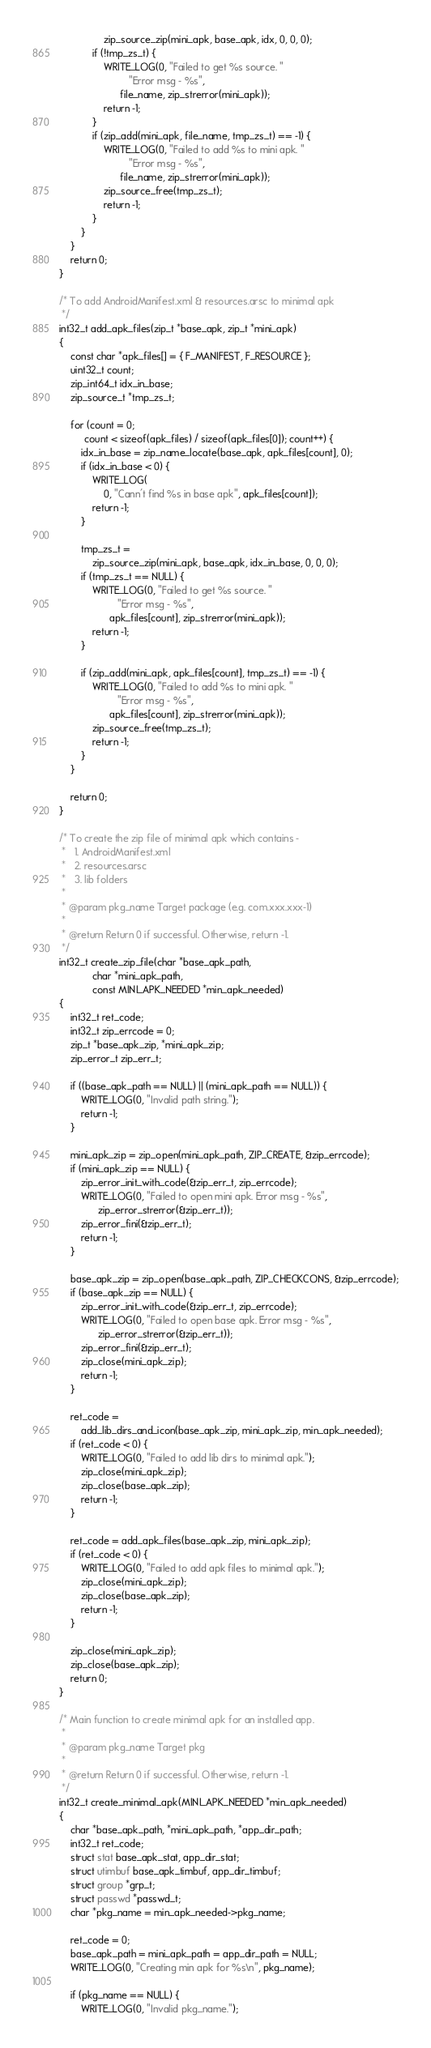<code> <loc_0><loc_0><loc_500><loc_500><_C_>			    zip_source_zip(mini_apk, base_apk, idx, 0, 0, 0);
			if (!tmp_zs_t) {
				WRITE_LOG(0, "Failed to get %s source. "
					     "Error msg - %s",
					  file_name, zip_strerror(mini_apk));
				return -1;
			}
			if (zip_add(mini_apk, file_name, tmp_zs_t) == -1) {
				WRITE_LOG(0, "Failed to add %s to mini apk. "
					     "Error msg - %s",
					  file_name, zip_strerror(mini_apk));
				zip_source_free(tmp_zs_t);
				return -1;
			}
		}
	}
	return 0;
}

/* To add AndroidManifest.xml & resources.arsc to minimal apk
 */
int32_t add_apk_files(zip_t *base_apk, zip_t *mini_apk)
{
	const char *apk_files[] = { F_MANIFEST, F_RESOURCE };
	uint32_t count;
	zip_int64_t idx_in_base;
	zip_source_t *tmp_zs_t;

	for (count = 0;
	     count < sizeof(apk_files) / sizeof(apk_files[0]); count++) {
		idx_in_base = zip_name_locate(base_apk, apk_files[count], 0);
		if (idx_in_base < 0) {
			WRITE_LOG(
			    0, "Cann't find %s in base apk", apk_files[count]);
			return -1;
		}

		tmp_zs_t =
		    zip_source_zip(mini_apk, base_apk, idx_in_base, 0, 0, 0);
		if (tmp_zs_t == NULL) {
			WRITE_LOG(0, "Failed to get %s source. "
				     "Error msg - %s",
				  apk_files[count], zip_strerror(mini_apk));
			return -1;
		}

		if (zip_add(mini_apk, apk_files[count], tmp_zs_t) == -1) {
			WRITE_LOG(0, "Failed to add %s to mini apk. "
				     "Error msg - %s",
				  apk_files[count], zip_strerror(mini_apk));
			zip_source_free(tmp_zs_t);
			return -1;
		}
	}

	return 0;
}

/* To create the zip file of minimal apk which contains -
 *   1. AndroidManifest.xml
 *   2. resources.arsc
 *   3. lib folders
 *
 * @param pkg_name Target package (e.g. com.xxx.xxx-1)
 *
 * @return Return 0 if successful. Otherwise, return -1.
 */
int32_t create_zip_file(char *base_apk_path,
			char *mini_apk_path,
			const MINI_APK_NEEDED *min_apk_needed)
{
	int32_t ret_code;
	int32_t zip_errcode = 0;
	zip_t *base_apk_zip, *mini_apk_zip;
	zip_error_t zip_err_t;

	if ((base_apk_path == NULL) || (mini_apk_path == NULL)) {
		WRITE_LOG(0, "Invalid path string.");
		return -1;
	}

	mini_apk_zip = zip_open(mini_apk_path, ZIP_CREATE, &zip_errcode);
	if (mini_apk_zip == NULL) {
		zip_error_init_with_code(&zip_err_t, zip_errcode);
		WRITE_LOG(0, "Failed to open mini apk. Error msg - %s",
			  zip_error_strerror(&zip_err_t));
		zip_error_fini(&zip_err_t);
		return -1;
	}

	base_apk_zip = zip_open(base_apk_path, ZIP_CHECKCONS, &zip_errcode);
	if (base_apk_zip == NULL) {
		zip_error_init_with_code(&zip_err_t, zip_errcode);
		WRITE_LOG(0, "Failed to open base apk. Error msg - %s",
			  zip_error_strerror(&zip_err_t));
		zip_error_fini(&zip_err_t);
		zip_close(mini_apk_zip);
		return -1;
	}

	ret_code =
	    add_lib_dirs_and_icon(base_apk_zip, mini_apk_zip, min_apk_needed);
	if (ret_code < 0) {
		WRITE_LOG(0, "Failed to add lib dirs to minimal apk.");
		zip_close(mini_apk_zip);
		zip_close(base_apk_zip);
		return -1;
	}

	ret_code = add_apk_files(base_apk_zip, mini_apk_zip);
	if (ret_code < 0) {
		WRITE_LOG(0, "Failed to add apk files to minimal apk.");
		zip_close(mini_apk_zip);
		zip_close(base_apk_zip);
		return -1;
	}

	zip_close(mini_apk_zip);
	zip_close(base_apk_zip);
	return 0;
}

/* Main function to create minimal apk for an installed app.
 *
 * @param pkg_name Target pkg
 *
 * @return Return 0 if successful. Otherwise, return -1.
 */
int32_t create_minimal_apk(MINI_APK_NEEDED *min_apk_needed)
{
	char *base_apk_path, *mini_apk_path, *app_dir_path;
	int32_t ret_code;
	struct stat base_apk_stat, app_dir_stat;
	struct utimbuf base_apk_timbuf, app_dir_timbuf;
	struct group *grp_t;
	struct passwd *passwd_t;
	char *pkg_name = min_apk_needed->pkg_name;

	ret_code = 0;
	base_apk_path = mini_apk_path = app_dir_path = NULL;
	WRITE_LOG(0, "Creating min apk for %s\n", pkg_name);

	if (pkg_name == NULL) {
		WRITE_LOG(0, "Invalid pkg_name.");</code> 